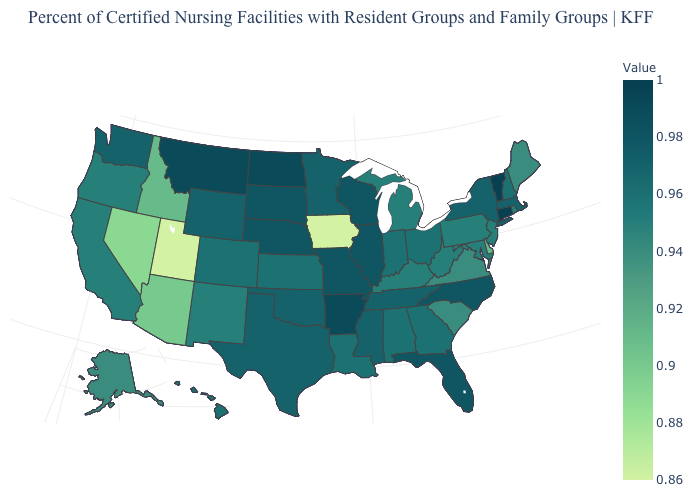Does Texas have a lower value than Maryland?
Quick response, please. No. Does Connecticut have the highest value in the Northeast?
Short answer required. Yes. Does North Carolina have the highest value in the USA?
Give a very brief answer. No. Does North Carolina have the lowest value in the USA?
Short answer required. No. 